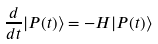Convert formula to latex. <formula><loc_0><loc_0><loc_500><loc_500>\frac { d } { d t } | P ( t ) \rangle = - H | P ( t ) \rangle</formula> 